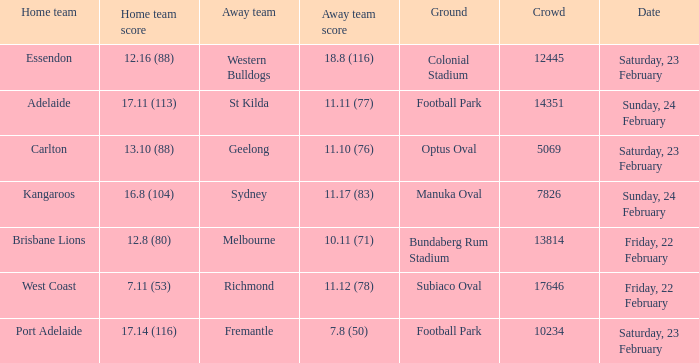Where the home team scored 13.10 (88), what was the size of the crowd? 5069.0. 